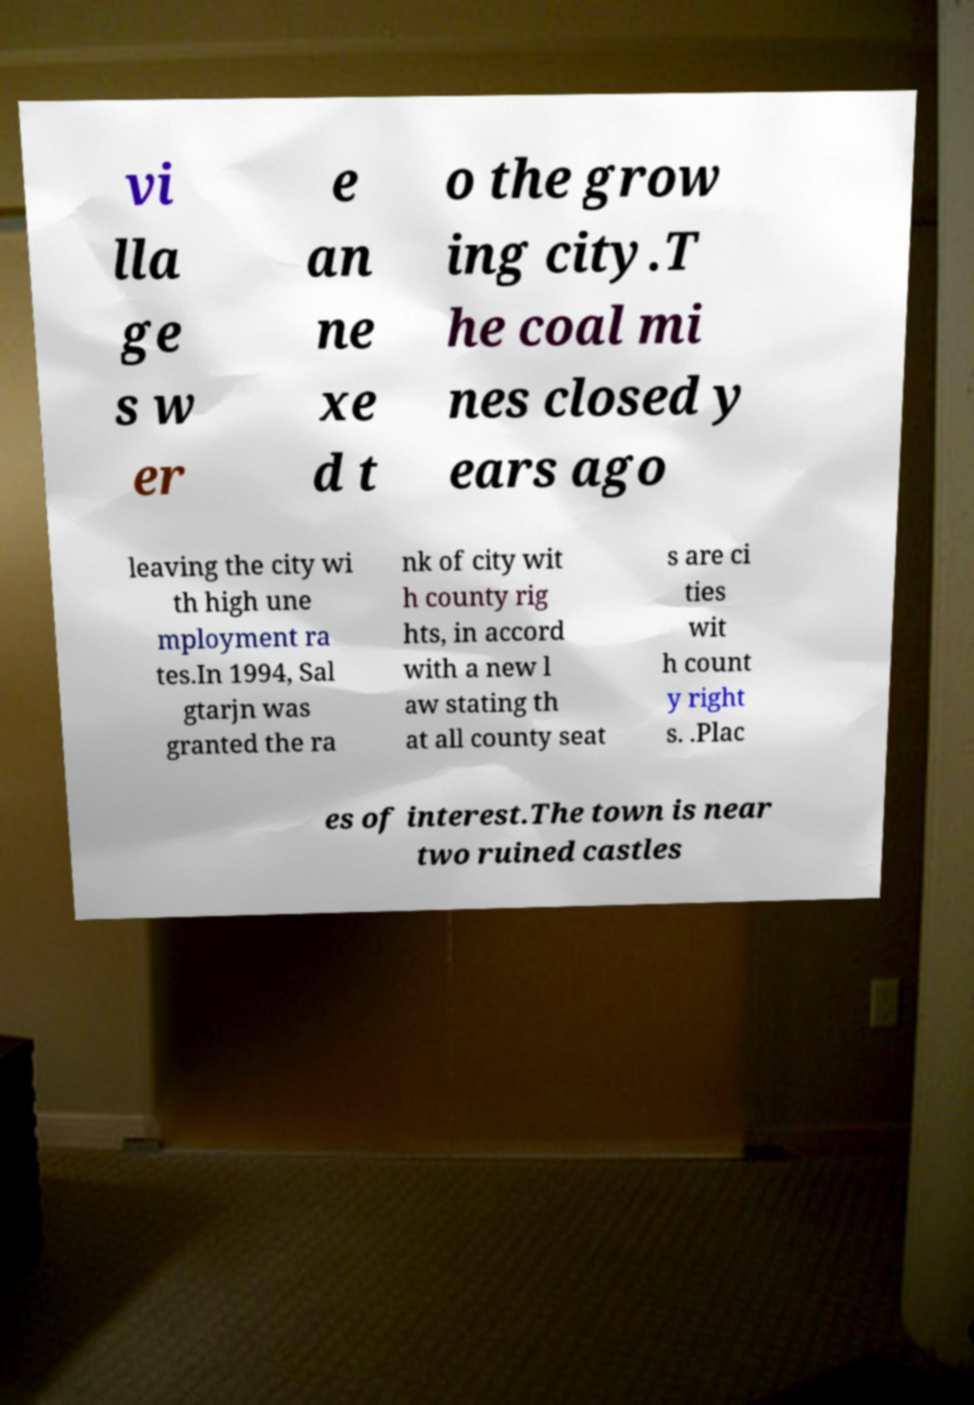Can you accurately transcribe the text from the provided image for me? vi lla ge s w er e an ne xe d t o the grow ing city.T he coal mi nes closed y ears ago leaving the city wi th high une mployment ra tes.In 1994, Sal gtarjn was granted the ra nk of city wit h county rig hts, in accord with a new l aw stating th at all county seat s are ci ties wit h count y right s. .Plac es of interest.The town is near two ruined castles 